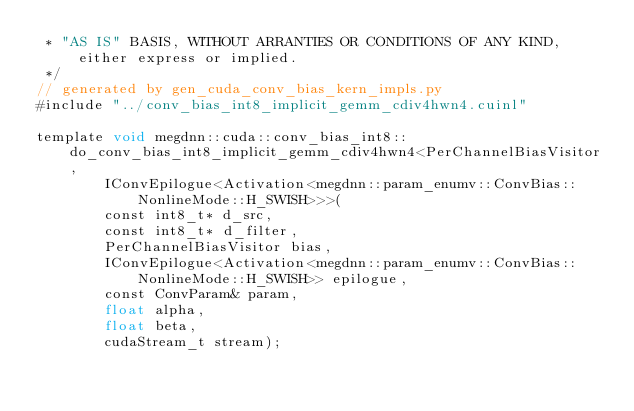<code> <loc_0><loc_0><loc_500><loc_500><_Cuda_> * "AS IS" BASIS, WITHOUT ARRANTIES OR CONDITIONS OF ANY KIND, either express or implied.
 */
// generated by gen_cuda_conv_bias_kern_impls.py
#include "../conv_bias_int8_implicit_gemm_cdiv4hwn4.cuinl"

template void megdnn::cuda::conv_bias_int8::do_conv_bias_int8_implicit_gemm_cdiv4hwn4<PerChannelBiasVisitor, 
        IConvEpilogue<Activation<megdnn::param_enumv::ConvBias::NonlineMode::H_SWISH>>>(
        const int8_t* d_src, 
        const int8_t* d_filter, 
        PerChannelBiasVisitor bias, 
        IConvEpilogue<Activation<megdnn::param_enumv::ConvBias::NonlineMode::H_SWISH>> epilogue, 
        const ConvParam& param, 
        float alpha, 
        float beta, 
        cudaStream_t stream);
</code> 